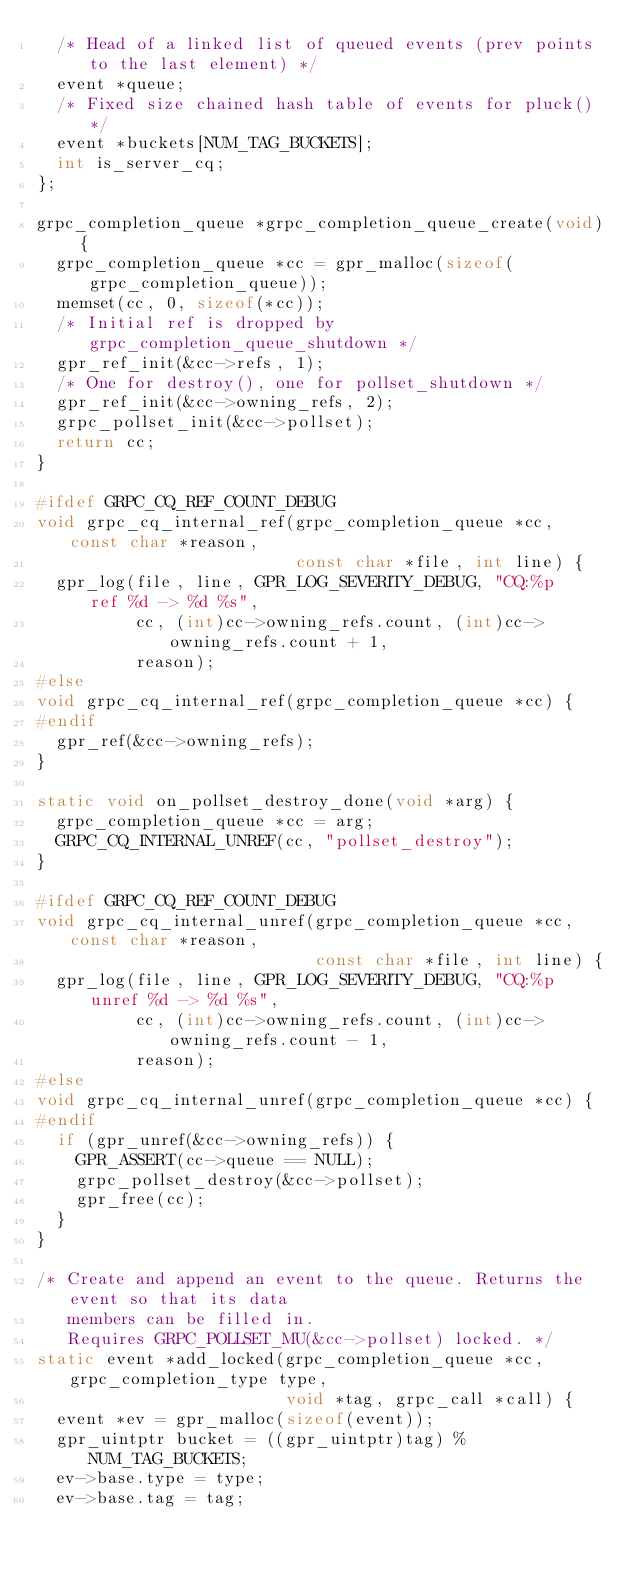<code> <loc_0><loc_0><loc_500><loc_500><_C_>  /* Head of a linked list of queued events (prev points to the last element) */
  event *queue;
  /* Fixed size chained hash table of events for pluck() */
  event *buckets[NUM_TAG_BUCKETS];
  int is_server_cq;
};

grpc_completion_queue *grpc_completion_queue_create(void) {
  grpc_completion_queue *cc = gpr_malloc(sizeof(grpc_completion_queue));
  memset(cc, 0, sizeof(*cc));
  /* Initial ref is dropped by grpc_completion_queue_shutdown */
  gpr_ref_init(&cc->refs, 1);
  /* One for destroy(), one for pollset_shutdown */
  gpr_ref_init(&cc->owning_refs, 2);
  grpc_pollset_init(&cc->pollset);
  return cc;
}

#ifdef GRPC_CQ_REF_COUNT_DEBUG
void grpc_cq_internal_ref(grpc_completion_queue *cc, const char *reason,
                          const char *file, int line) {
  gpr_log(file, line, GPR_LOG_SEVERITY_DEBUG, "CQ:%p   ref %d -> %d %s",
          cc, (int)cc->owning_refs.count, (int)cc->owning_refs.count + 1,
          reason);
#else
void grpc_cq_internal_ref(grpc_completion_queue *cc) {
#endif
  gpr_ref(&cc->owning_refs);
}

static void on_pollset_destroy_done(void *arg) {
  grpc_completion_queue *cc = arg;
  GRPC_CQ_INTERNAL_UNREF(cc, "pollset_destroy");
}

#ifdef GRPC_CQ_REF_COUNT_DEBUG
void grpc_cq_internal_unref(grpc_completion_queue *cc, const char *reason,
                            const char *file, int line) {
  gpr_log(file, line, GPR_LOG_SEVERITY_DEBUG, "CQ:%p unref %d -> %d %s",
          cc, (int)cc->owning_refs.count, (int)cc->owning_refs.count - 1,
          reason);
#else
void grpc_cq_internal_unref(grpc_completion_queue *cc) {
#endif
  if (gpr_unref(&cc->owning_refs)) {
    GPR_ASSERT(cc->queue == NULL);
    grpc_pollset_destroy(&cc->pollset);
    gpr_free(cc);
  }
}

/* Create and append an event to the queue. Returns the event so that its data
   members can be filled in.
   Requires GRPC_POLLSET_MU(&cc->pollset) locked. */
static event *add_locked(grpc_completion_queue *cc, grpc_completion_type type,
                         void *tag, grpc_call *call) {
  event *ev = gpr_malloc(sizeof(event));
  gpr_uintptr bucket = ((gpr_uintptr)tag) % NUM_TAG_BUCKETS;
  ev->base.type = type;
  ev->base.tag = tag;</code> 